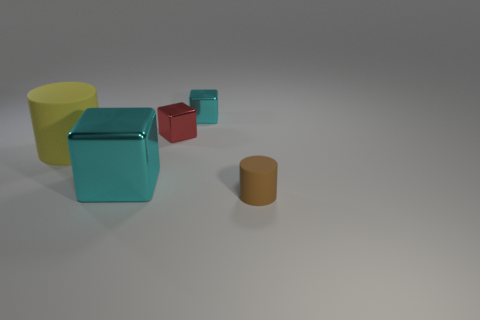Subtract all brown cylinders. How many cyan blocks are left? 2 Add 3 purple rubber objects. How many objects exist? 8 Subtract all red metallic cubes. How many cubes are left? 2 Subtract 1 cubes. How many cubes are left? 2 Subtract all blocks. How many objects are left? 2 Add 4 tiny red metal blocks. How many tiny red metal blocks exist? 5 Subtract 0 purple balls. How many objects are left? 5 Subtract all cyan cylinders. Subtract all gray balls. How many cylinders are left? 2 Subtract all small green rubber objects. Subtract all cyan metal cubes. How many objects are left? 3 Add 1 cyan objects. How many cyan objects are left? 3 